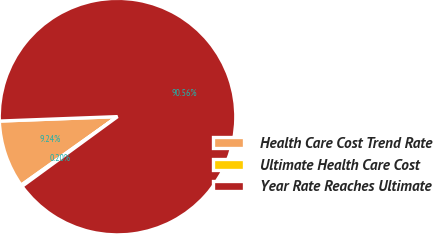<chart> <loc_0><loc_0><loc_500><loc_500><pie_chart><fcel>Health Care Cost Trend Rate<fcel>Ultimate Health Care Cost<fcel>Year Rate Reaches Ultimate<nl><fcel>9.24%<fcel>0.2%<fcel>90.56%<nl></chart> 